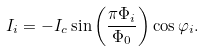Convert formula to latex. <formula><loc_0><loc_0><loc_500><loc_500>I _ { i } = - I _ { c } \sin \left ( \frac { \pi \Phi _ { i } } { \Phi _ { 0 } } \right ) \cos \varphi _ { i } .</formula> 